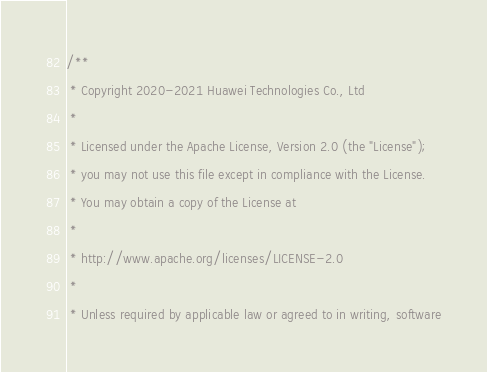Convert code to text. <code><loc_0><loc_0><loc_500><loc_500><_C++_>/**
 * Copyright 2020-2021 Huawei Technologies Co., Ltd
 *
 * Licensed under the Apache License, Version 2.0 (the "License");
 * you may not use this file except in compliance with the License.
 * You may obtain a copy of the License at
 *
 * http://www.apache.org/licenses/LICENSE-2.0
 *
 * Unless required by applicable law or agreed to in writing, software</code> 